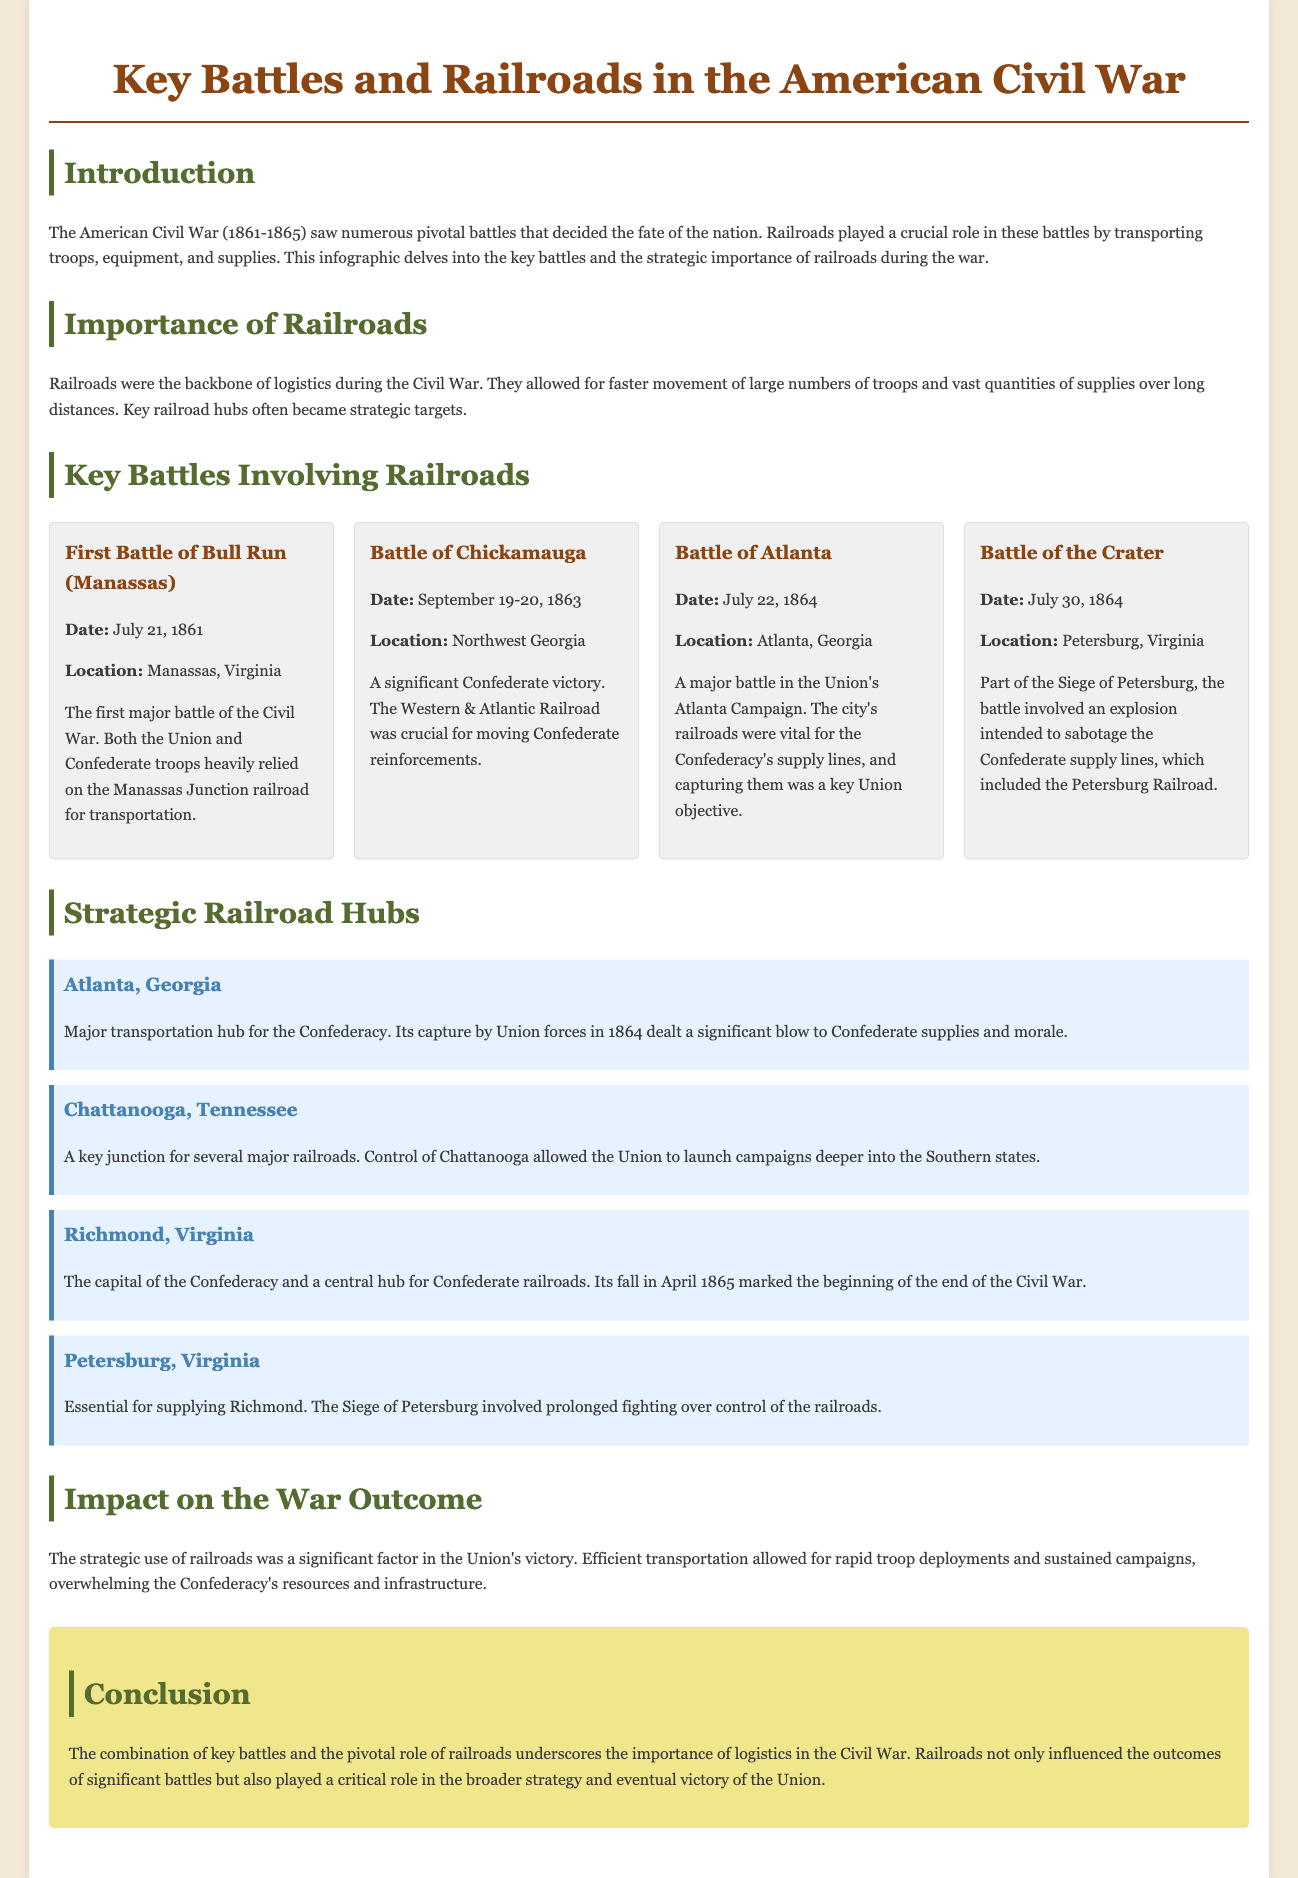What was the first major battle of the Civil War? The document states that the First Battle of Bull Run (Manassas) was the first major battle of the Civil War.
Answer: First Battle of Bull Run (Manassas) On what date did the Battle of Atlanta occur? The document lists the date of the Battle of Atlanta as July 22, 1864.
Answer: July 22, 1864 Which railroad was crucial for moving Confederate reinforcements during the Battle of Chickamauga? The document indicates that the Western & Atlantic Railroad was crucial for this battle.
Answer: Western & Atlantic Railroad What role did railroads play according to the document? The document states that railroads were the backbone of logistics during the Civil War, enabling faster troop and supply movement.
Answer: Backbone of logistics What was a major impact of the strategic use of railroads in the war? The document mentions that the strategic use of railroads was significant for the Union's victory, allowing rapid troop deployments.
Answer: Union's victory Which city served as a major transportation hub for the Confederacy? According to the document, Atlanta, Georgia served as a major transportation hub for the Confederacy.
Answer: Atlanta, Georgia What battle involved an explosion intended to sabotage Confederate supply lines? The document notes that the Battle of the Crater involved such an explosion.
Answer: Battle of the Crater What was the capital of the Confederacy? The document states that Richmond, Virginia was the capital of the Confederacy.
Answer: Richmond, Virginia 